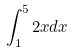Convert formula to latex. <formula><loc_0><loc_0><loc_500><loc_500>\int _ { 1 } ^ { 5 } 2 x d x</formula> 